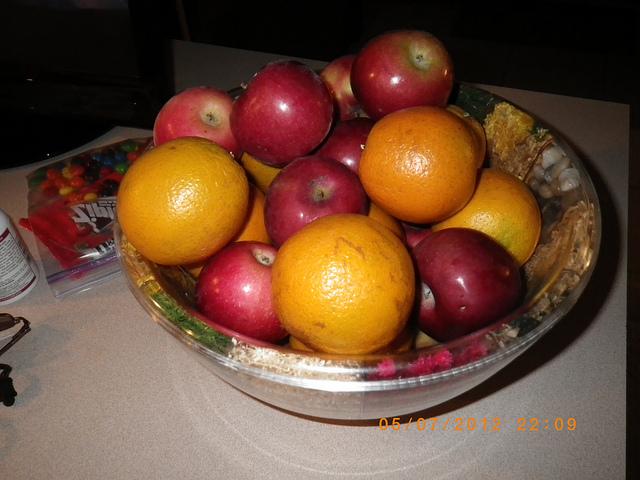How many kinds of fruit are in the image?
Give a very brief answer. 2. Does the fruit on the bottom have an angry face?
Keep it brief. No. What kind of fruit is in the bowl?
Give a very brief answer. Apples and oranges. Are all the fruits in a bowl?
Short answer required. Yes. Is fruit good for you?
Concise answer only. Yes. Can you use some of these items to make guacamole?
Concise answer only. No. What is going to happen to the oranges?
Keep it brief. Eaten. Is the light source in the photo directly above the objects or placed low and to the right?
Write a very short answer. Above. How long can you keep fruit in a box?
Be succinct. Week. Is the fruit rotten?
Keep it brief. No. Are there any limes?
Keep it brief. No. Are these apples all the same color?
Concise answer only. Yes. What is in the bowl?
Quick response, please. Fruit. How many fruits are in the bowl?
Answer briefly. 18. 